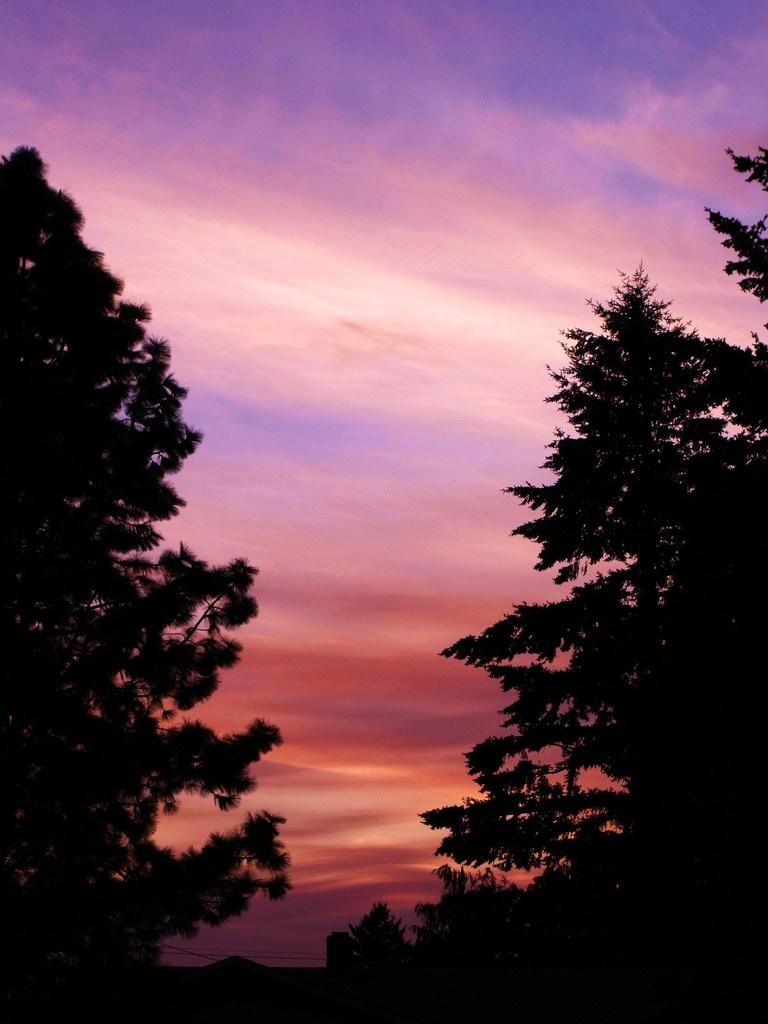What type of natural elements can be seen in the image? There are trees in the image. What man-made objects are present in the image? There are wires in the image. What can be seen in the background of the image? The sky is visible in the background of the image. What atmospheric conditions are depicted in the sky? Clouds are present in the sky. How many cats are sitting on the selection of buckets in the image? There are no cats or buckets present in the image. 